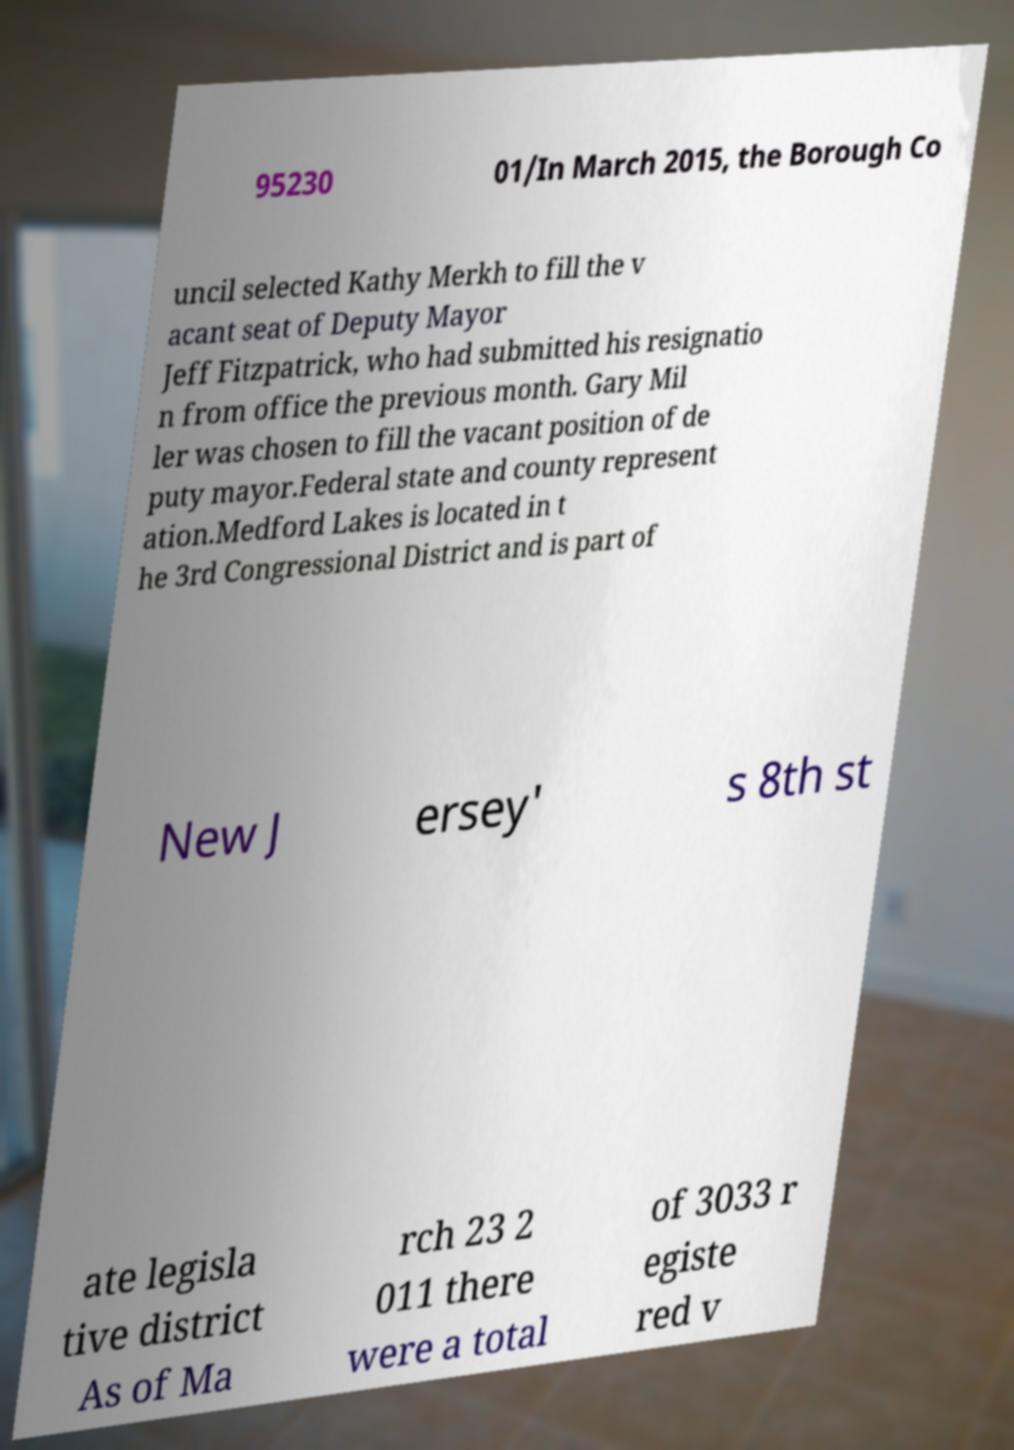For documentation purposes, I need the text within this image transcribed. Could you provide that? 95230 01/In March 2015, the Borough Co uncil selected Kathy Merkh to fill the v acant seat of Deputy Mayor Jeff Fitzpatrick, who had submitted his resignatio n from office the previous month. Gary Mil ler was chosen to fill the vacant position of de puty mayor.Federal state and county represent ation.Medford Lakes is located in t he 3rd Congressional District and is part of New J ersey' s 8th st ate legisla tive district As of Ma rch 23 2 011 there were a total of 3033 r egiste red v 